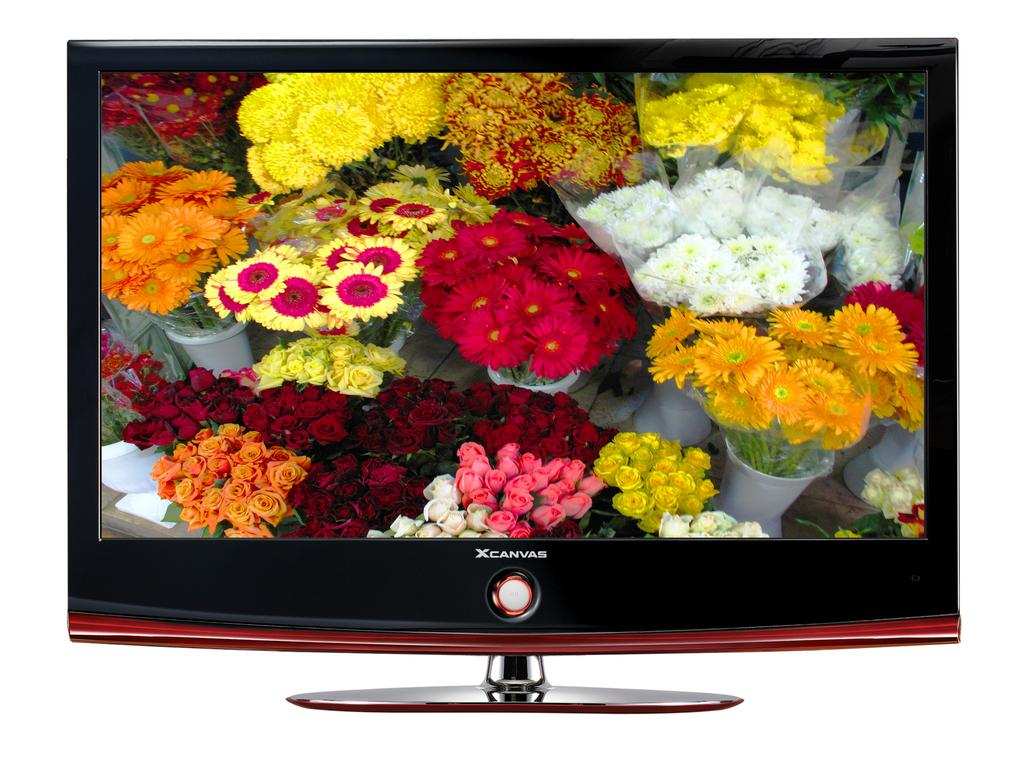Provide a one-sentence caption for the provided image. Television Screen of Flowers that say X Canvas on it. 